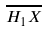<formula> <loc_0><loc_0><loc_500><loc_500>\overline { H _ { 1 } X }</formula> 